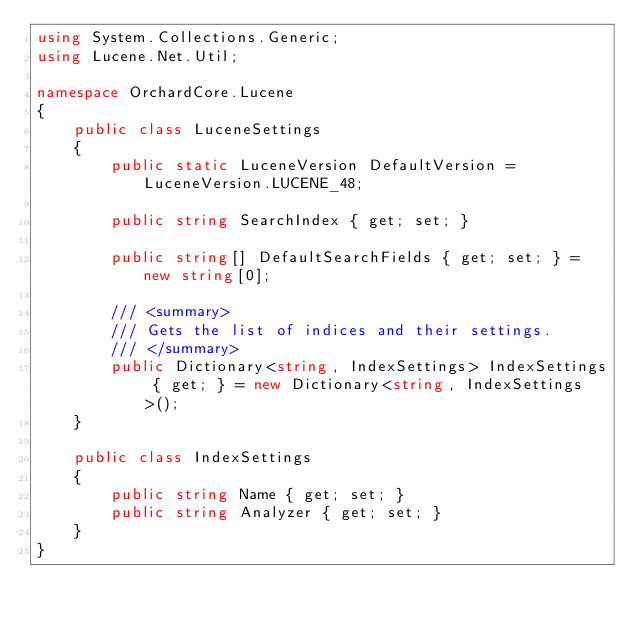Convert code to text. <code><loc_0><loc_0><loc_500><loc_500><_C#_>using System.Collections.Generic;
using Lucene.Net.Util;

namespace OrchardCore.Lucene
{
    public class LuceneSettings
    {
        public static LuceneVersion DefaultVersion = LuceneVersion.LUCENE_48;

        public string SearchIndex { get; set; }

        public string[] DefaultSearchFields { get; set; } = new string[0];

        /// <summary>
        /// Gets the list of indices and their settings.
        /// </summary>
        public Dictionary<string, IndexSettings> IndexSettings { get; } = new Dictionary<string, IndexSettings>();
    }

    public class IndexSettings
    {
        public string Name { get; set; }
        public string Analyzer { get; set; }
    }
}
</code> 